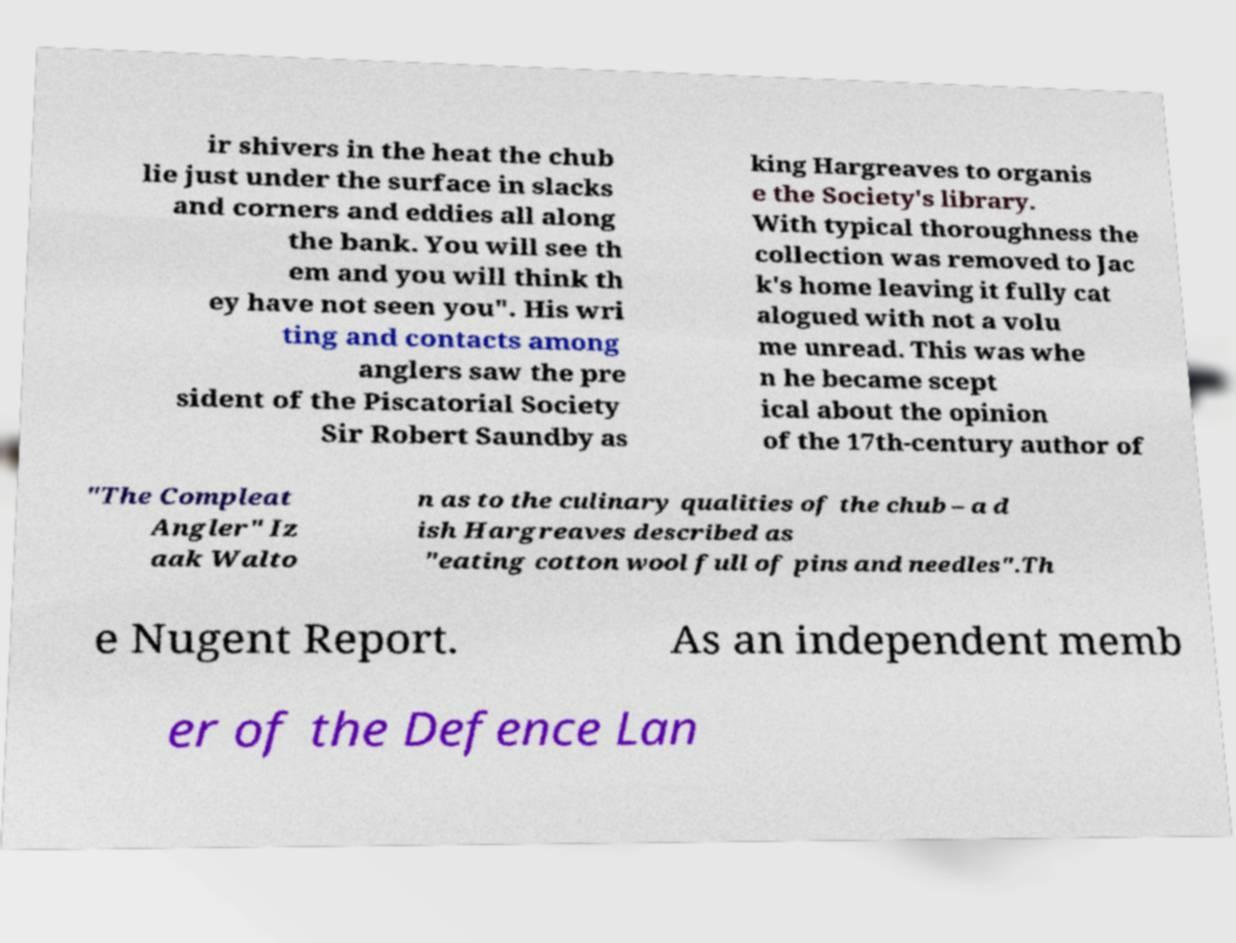I need the written content from this picture converted into text. Can you do that? ir shivers in the heat the chub lie just under the surface in slacks and corners and eddies all along the bank. You will see th em and you will think th ey have not seen you". His wri ting and contacts among anglers saw the pre sident of the Piscatorial Society Sir Robert Saundby as king Hargreaves to organis e the Society's library. With typical thoroughness the collection was removed to Jac k's home leaving it fully cat alogued with not a volu me unread. This was whe n he became scept ical about the opinion of the 17th-century author of "The Compleat Angler" Iz aak Walto n as to the culinary qualities of the chub – a d ish Hargreaves described as "eating cotton wool full of pins and needles".Th e Nugent Report. As an independent memb er of the Defence Lan 